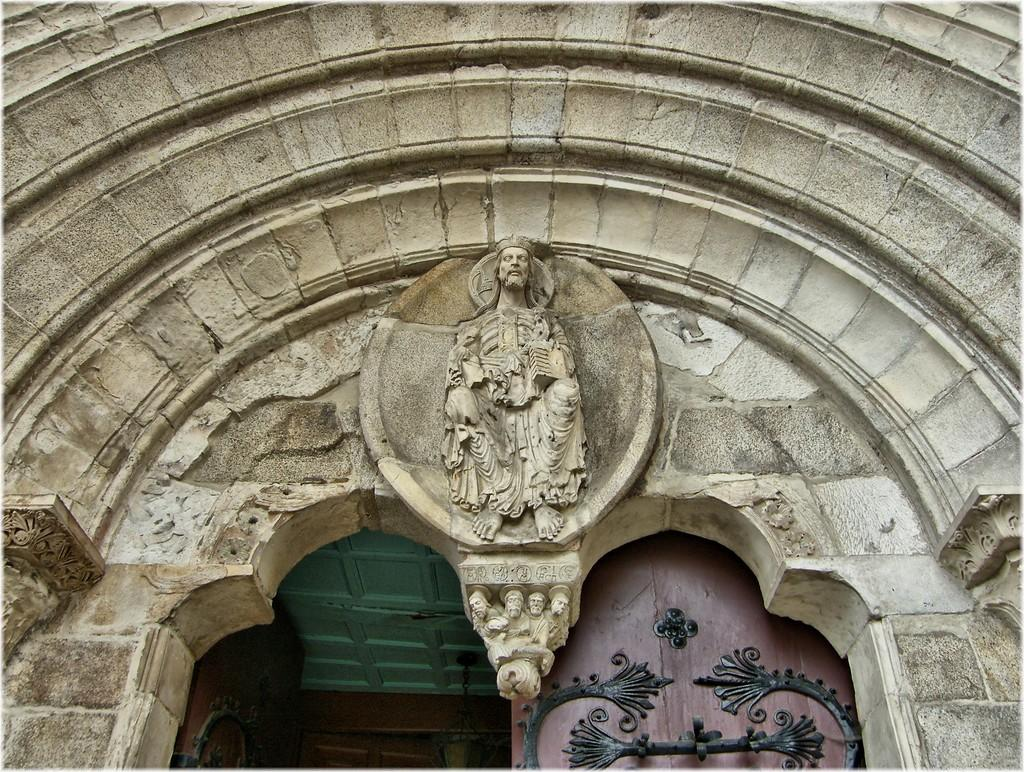What is the main subject of the image? The main subject of the image is the top of a building. Are there any specific features on the building? Yes, there is an architectural design of a person on the wall of the building. How can one access the building? There is an entrance door to the building. What type of slope can be seen in the image? There is no slope present in the image; it shows the top of a building with an architectural design and an entrance door. Is there a fork visible in the image? There is no fork present in the image. 